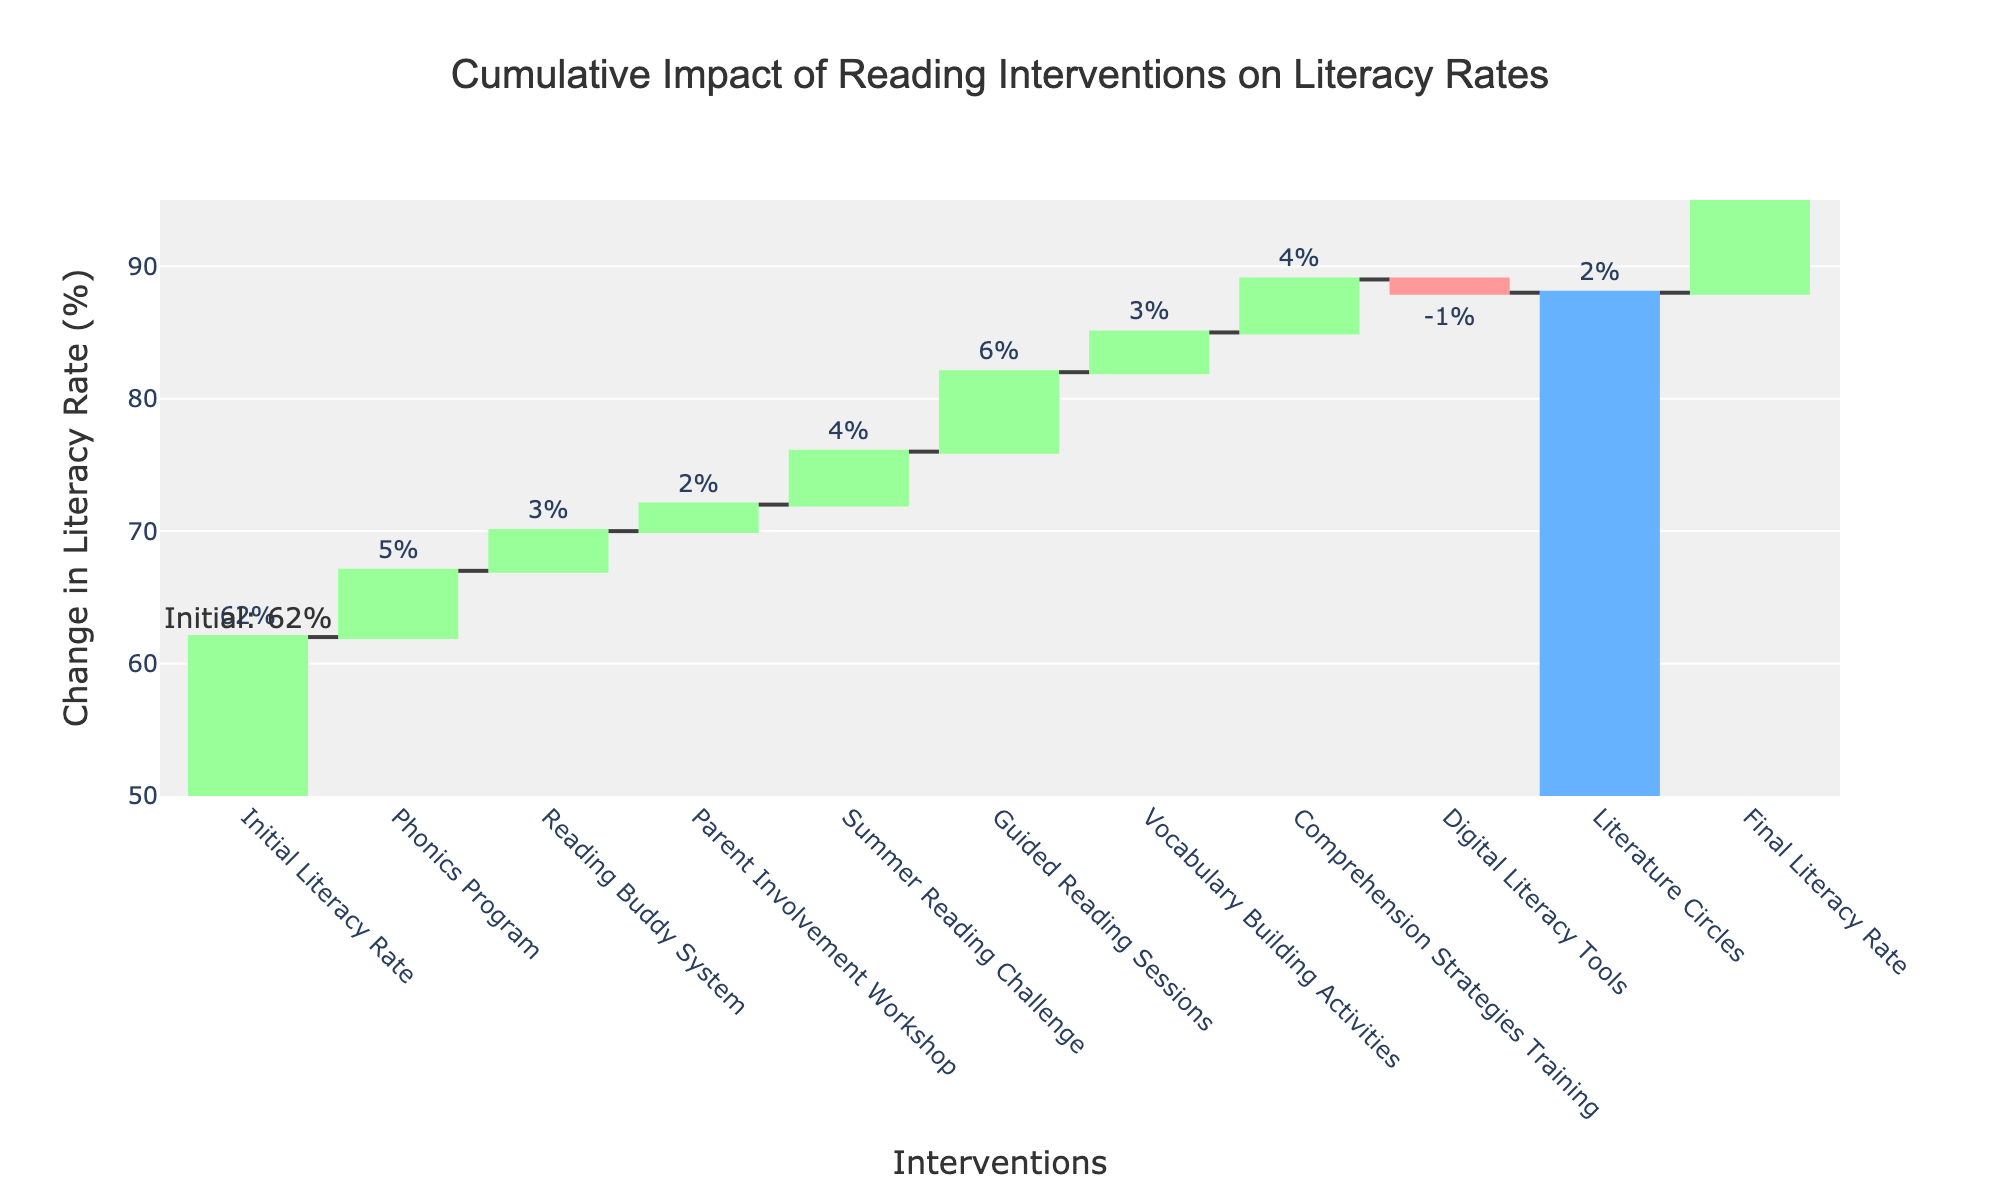What is the title of the chart? The title is generally located at the top center of the chart and is usually larger in font size than other text. Here, it states, "Cumulative Impact of Reading Interventions on Literacy Rates."
Answer: Cumulative Impact of Reading Interventions on Literacy Rates What is the initial literacy rate? Look for the first data point in the chart, typically labeled as the "Initial Literacy Rate". It is explicitly annotated in the chart.
Answer: 62% How many interventions have a positive impact on the literacy rate? Count the number of bars with positive values in the waterfall chart. These bars are typically represented with a color indicating increase, such as a green bar.
Answer: 9 Which intervention had a negative impact on the literacy rate? Identify any bar that decreases from the previous value. These bars are usually marked with a different color, like red, indicating a negative impact. Here, "Digital Literacy Tools" had a negative value.
Answer: Digital Literacy Tools What is the final literacy rate? Locate the final bar in the chart, which is commonly labeled and marked as the total. It shows the overall change after all interventions.
Answer: 90% How much did the guided reading sessions contribute to the literacy rate increase? Look for the bar labeled as "Guided Reading Sessions" and note its value. This value indicates the contribution to the literacy rate.
Answer: 6% How many literacy rate points were added through "Phonics Program" and "Summer Reading Challenge" combined? Locate the values for both "Phonics Program" and "Summer Reading Challenge," then sum them up. In this case, 5% + 4% = 9%.
Answer: 9% Which intervention contributed more to the literacy rate, "Vocabulary Building Activities" or "Literacy Circles"? Compare the values indicated for both bars. "Vocabulary Building Activities" contributed 3%, and "Literature Circles" contributed 2%.
Answer: Vocabulary Building Activities What is the difference in literacy rate improvement between "Comprehension Strategies Training" and "Parent Involvement Workshop"? Find the values for both interventions and subtract one from the other. "Comprehension Strategies Training" contributed 4%, and "Parent Involvement Workshop" contributed 2%; the difference is 4% - 2% = 2%.
Answer: 2% How much did the overall literacy rate change due to all interventions combined? Subtract the initial literacy rate from the final literacy rate. Final = 90%, Initial = 62%. Hence, 90% - 62% = 28%.
Answer: 28% 